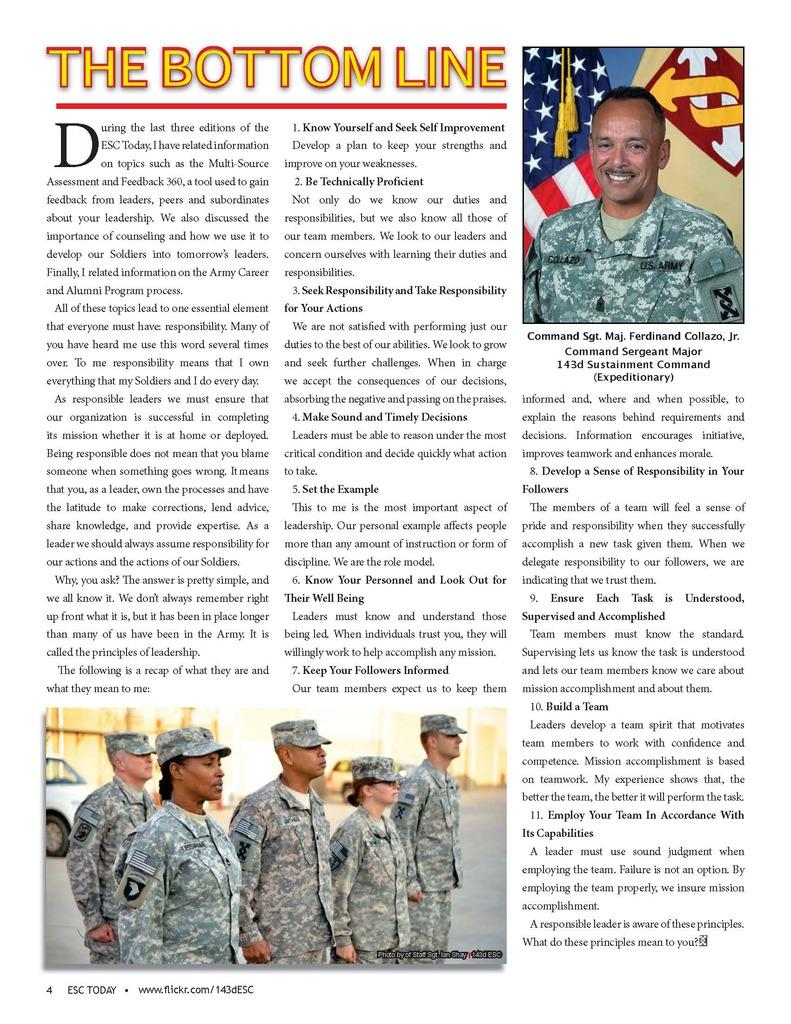What type of content is featured in the image? There is an article in the image. What kind of article is it? The article is from an editorial. Are there any visual elements in the article? Yes, there are pictures in the article. How is the text conveyed in the article? There are words printed in the article. What type of shock can be seen in the article? There is no shock present in the article; it is a written piece of content with pictures and printed words. What role does the straw play in the article? There is no straw mentioned or depicted in the article. 